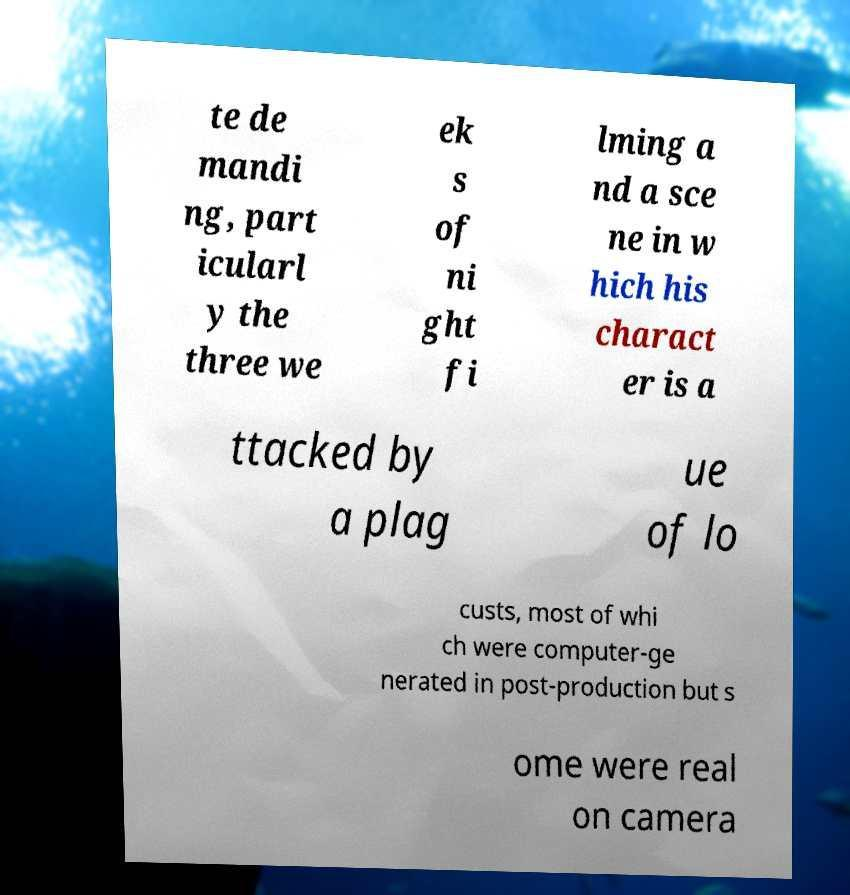Could you assist in decoding the text presented in this image and type it out clearly? te de mandi ng, part icularl y the three we ek s of ni ght fi lming a nd a sce ne in w hich his charact er is a ttacked by a plag ue of lo custs, most of whi ch were computer-ge nerated in post-production but s ome were real on camera 